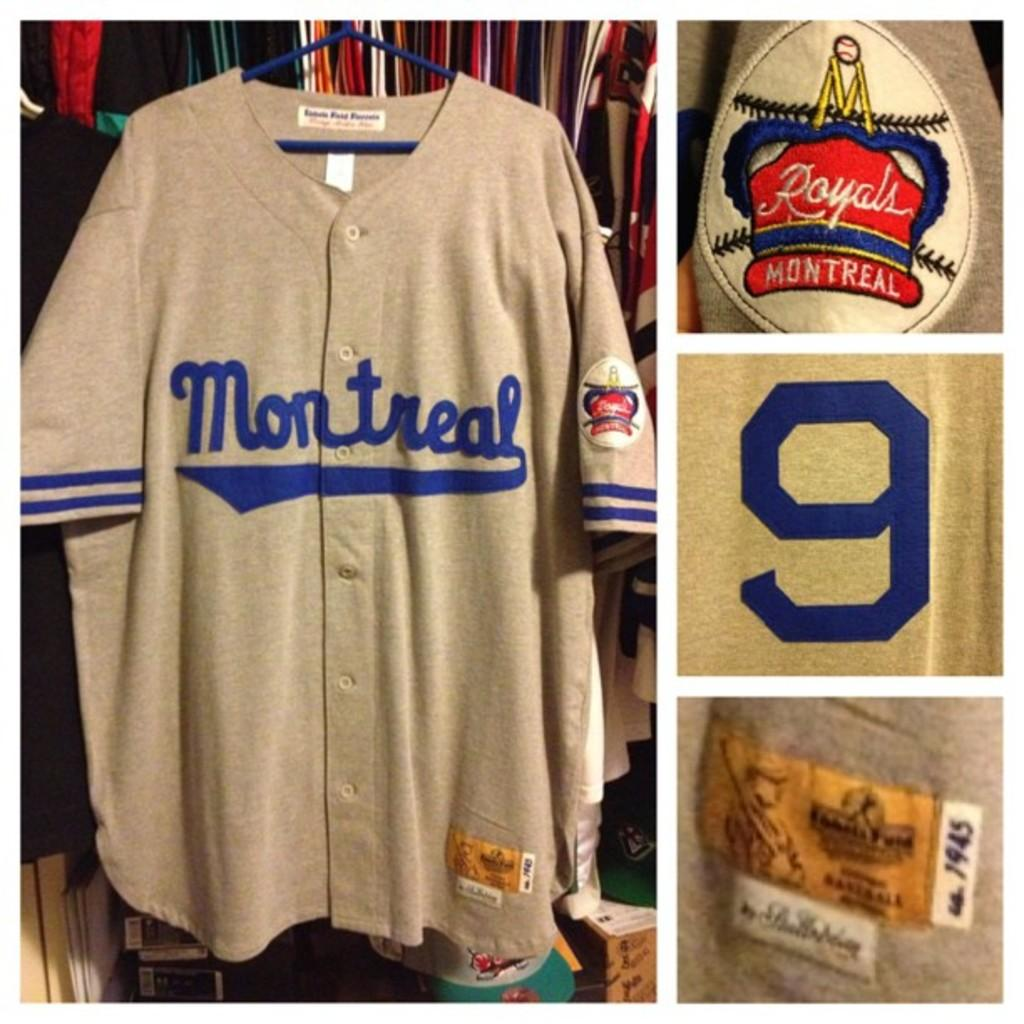<image>
Provide a brief description of the given image. A jersey from the Royal's montreal team displaying the number 9 